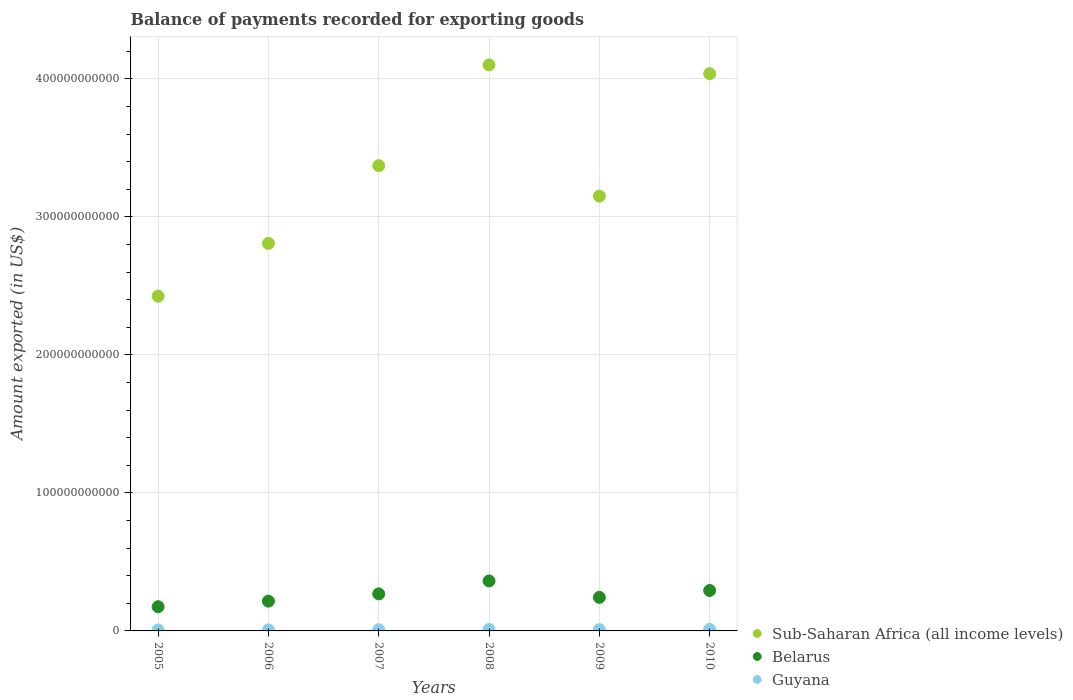How many different coloured dotlines are there?
Provide a succinct answer. 3. Is the number of dotlines equal to the number of legend labels?
Provide a succinct answer. Yes. What is the amount exported in Guyana in 2006?
Provide a short and direct response. 7.27e+08. Across all years, what is the maximum amount exported in Sub-Saharan Africa (all income levels)?
Provide a succinct answer. 4.10e+11. Across all years, what is the minimum amount exported in Guyana?
Your answer should be compact. 6.93e+08. In which year was the amount exported in Guyana maximum?
Offer a terse response. 2010. What is the total amount exported in Belarus in the graph?
Keep it short and to the point. 1.56e+11. What is the difference between the amount exported in Sub-Saharan Africa (all income levels) in 2005 and that in 2008?
Your answer should be very brief. -1.68e+11. What is the difference between the amount exported in Guyana in 2006 and the amount exported in Sub-Saharan Africa (all income levels) in 2007?
Make the answer very short. -3.36e+11. What is the average amount exported in Guyana per year?
Make the answer very short. 8.90e+08. In the year 2008, what is the difference between the amount exported in Belarus and amount exported in Sub-Saharan Africa (all income levels)?
Provide a short and direct response. -3.74e+11. What is the ratio of the amount exported in Belarus in 2007 to that in 2008?
Your response must be concise. 0.74. Is the amount exported in Sub-Saharan Africa (all income levels) in 2005 less than that in 2006?
Offer a terse response. Yes. Is the difference between the amount exported in Belarus in 2009 and 2010 greater than the difference between the amount exported in Sub-Saharan Africa (all income levels) in 2009 and 2010?
Your response must be concise. Yes. What is the difference between the highest and the second highest amount exported in Guyana?
Give a very brief answer. 1.06e+08. What is the difference between the highest and the lowest amount exported in Guyana?
Offer a very short reply. 4.26e+08. Is the sum of the amount exported in Guyana in 2005 and 2008 greater than the maximum amount exported in Belarus across all years?
Give a very brief answer. No. Does the amount exported in Sub-Saharan Africa (all income levels) monotonically increase over the years?
Your answer should be very brief. No. What is the difference between two consecutive major ticks on the Y-axis?
Make the answer very short. 1.00e+11. Does the graph contain grids?
Your response must be concise. Yes. How many legend labels are there?
Provide a succinct answer. 3. How are the legend labels stacked?
Offer a terse response. Vertical. What is the title of the graph?
Provide a short and direct response. Balance of payments recorded for exporting goods. Does "Nigeria" appear as one of the legend labels in the graph?
Your response must be concise. No. What is the label or title of the X-axis?
Your answer should be very brief. Years. What is the label or title of the Y-axis?
Give a very brief answer. Amount exported (in US$). What is the Amount exported (in US$) of Sub-Saharan Africa (all income levels) in 2005?
Make the answer very short. 2.43e+11. What is the Amount exported (in US$) of Belarus in 2005?
Provide a succinct answer. 1.75e+1. What is the Amount exported (in US$) of Guyana in 2005?
Your answer should be very brief. 6.93e+08. What is the Amount exported (in US$) in Sub-Saharan Africa (all income levels) in 2006?
Offer a terse response. 2.81e+11. What is the Amount exported (in US$) of Belarus in 2006?
Offer a very short reply. 2.16e+1. What is the Amount exported (in US$) in Guyana in 2006?
Keep it short and to the point. 7.27e+08. What is the Amount exported (in US$) of Sub-Saharan Africa (all income levels) in 2007?
Your answer should be very brief. 3.37e+11. What is the Amount exported (in US$) of Belarus in 2007?
Offer a terse response. 2.69e+1. What is the Amount exported (in US$) in Guyana in 2007?
Make the answer very short. 8.48e+08. What is the Amount exported (in US$) of Sub-Saharan Africa (all income levels) in 2008?
Your answer should be compact. 4.10e+11. What is the Amount exported (in US$) of Belarus in 2008?
Provide a short and direct response. 3.62e+1. What is the Amount exported (in US$) of Guyana in 2008?
Ensure brevity in your answer.  1.01e+09. What is the Amount exported (in US$) of Sub-Saharan Africa (all income levels) in 2009?
Your answer should be very brief. 3.15e+11. What is the Amount exported (in US$) of Belarus in 2009?
Ensure brevity in your answer.  2.43e+1. What is the Amount exported (in US$) of Guyana in 2009?
Give a very brief answer. 9.38e+08. What is the Amount exported (in US$) of Sub-Saharan Africa (all income levels) in 2010?
Offer a very short reply. 4.04e+11. What is the Amount exported (in US$) in Belarus in 2010?
Make the answer very short. 2.93e+1. What is the Amount exported (in US$) in Guyana in 2010?
Your answer should be very brief. 1.12e+09. Across all years, what is the maximum Amount exported (in US$) of Sub-Saharan Africa (all income levels)?
Give a very brief answer. 4.10e+11. Across all years, what is the maximum Amount exported (in US$) in Belarus?
Offer a terse response. 3.62e+1. Across all years, what is the maximum Amount exported (in US$) of Guyana?
Your response must be concise. 1.12e+09. Across all years, what is the minimum Amount exported (in US$) in Sub-Saharan Africa (all income levels)?
Your response must be concise. 2.43e+11. Across all years, what is the minimum Amount exported (in US$) of Belarus?
Provide a short and direct response. 1.75e+1. Across all years, what is the minimum Amount exported (in US$) of Guyana?
Offer a terse response. 6.93e+08. What is the total Amount exported (in US$) in Sub-Saharan Africa (all income levels) in the graph?
Keep it short and to the point. 1.99e+12. What is the total Amount exported (in US$) in Belarus in the graph?
Provide a short and direct response. 1.56e+11. What is the total Amount exported (in US$) of Guyana in the graph?
Give a very brief answer. 5.34e+09. What is the difference between the Amount exported (in US$) of Sub-Saharan Africa (all income levels) in 2005 and that in 2006?
Keep it short and to the point. -3.83e+1. What is the difference between the Amount exported (in US$) in Belarus in 2005 and that in 2006?
Offer a very short reply. -4.03e+09. What is the difference between the Amount exported (in US$) of Guyana in 2005 and that in 2006?
Provide a short and direct response. -3.37e+07. What is the difference between the Amount exported (in US$) of Sub-Saharan Africa (all income levels) in 2005 and that in 2007?
Provide a succinct answer. -9.46e+1. What is the difference between the Amount exported (in US$) in Belarus in 2005 and that in 2007?
Offer a very short reply. -9.32e+09. What is the difference between the Amount exported (in US$) in Guyana in 2005 and that in 2007?
Keep it short and to the point. -1.54e+08. What is the difference between the Amount exported (in US$) of Sub-Saharan Africa (all income levels) in 2005 and that in 2008?
Keep it short and to the point. -1.68e+11. What is the difference between the Amount exported (in US$) of Belarus in 2005 and that in 2008?
Your answer should be very brief. -1.87e+1. What is the difference between the Amount exported (in US$) of Guyana in 2005 and that in 2008?
Your answer should be very brief. -3.20e+08. What is the difference between the Amount exported (in US$) of Sub-Saharan Africa (all income levels) in 2005 and that in 2009?
Ensure brevity in your answer.  -7.25e+1. What is the difference between the Amount exported (in US$) of Belarus in 2005 and that in 2009?
Your answer should be very brief. -6.77e+09. What is the difference between the Amount exported (in US$) in Guyana in 2005 and that in 2009?
Offer a terse response. -2.45e+08. What is the difference between the Amount exported (in US$) in Sub-Saharan Africa (all income levels) in 2005 and that in 2010?
Keep it short and to the point. -1.61e+11. What is the difference between the Amount exported (in US$) in Belarus in 2005 and that in 2010?
Offer a terse response. -1.18e+1. What is the difference between the Amount exported (in US$) in Guyana in 2005 and that in 2010?
Keep it short and to the point. -4.26e+08. What is the difference between the Amount exported (in US$) of Sub-Saharan Africa (all income levels) in 2006 and that in 2007?
Provide a short and direct response. -5.63e+1. What is the difference between the Amount exported (in US$) of Belarus in 2006 and that in 2007?
Provide a short and direct response. -5.28e+09. What is the difference between the Amount exported (in US$) in Guyana in 2006 and that in 2007?
Your response must be concise. -1.21e+08. What is the difference between the Amount exported (in US$) in Sub-Saharan Africa (all income levels) in 2006 and that in 2008?
Provide a succinct answer. -1.29e+11. What is the difference between the Amount exported (in US$) of Belarus in 2006 and that in 2008?
Keep it short and to the point. -1.46e+1. What is the difference between the Amount exported (in US$) of Guyana in 2006 and that in 2008?
Provide a short and direct response. -2.86e+08. What is the difference between the Amount exported (in US$) of Sub-Saharan Africa (all income levels) in 2006 and that in 2009?
Offer a very short reply. -3.43e+1. What is the difference between the Amount exported (in US$) of Belarus in 2006 and that in 2009?
Your response must be concise. -2.74e+09. What is the difference between the Amount exported (in US$) of Guyana in 2006 and that in 2009?
Offer a very short reply. -2.11e+08. What is the difference between the Amount exported (in US$) in Sub-Saharan Africa (all income levels) in 2006 and that in 2010?
Make the answer very short. -1.23e+11. What is the difference between the Amount exported (in US$) of Belarus in 2006 and that in 2010?
Your answer should be compact. -7.73e+09. What is the difference between the Amount exported (in US$) in Guyana in 2006 and that in 2010?
Provide a succinct answer. -3.92e+08. What is the difference between the Amount exported (in US$) in Sub-Saharan Africa (all income levels) in 2007 and that in 2008?
Offer a terse response. -7.31e+1. What is the difference between the Amount exported (in US$) of Belarus in 2007 and that in 2008?
Provide a succinct answer. -9.37e+09. What is the difference between the Amount exported (in US$) in Guyana in 2007 and that in 2008?
Make the answer very short. -1.66e+08. What is the difference between the Amount exported (in US$) of Sub-Saharan Africa (all income levels) in 2007 and that in 2009?
Keep it short and to the point. 2.20e+1. What is the difference between the Amount exported (in US$) of Belarus in 2007 and that in 2009?
Your answer should be compact. 2.54e+09. What is the difference between the Amount exported (in US$) of Guyana in 2007 and that in 2009?
Ensure brevity in your answer.  -9.07e+07. What is the difference between the Amount exported (in US$) of Sub-Saharan Africa (all income levels) in 2007 and that in 2010?
Provide a short and direct response. -6.67e+1. What is the difference between the Amount exported (in US$) of Belarus in 2007 and that in 2010?
Provide a succinct answer. -2.45e+09. What is the difference between the Amount exported (in US$) of Guyana in 2007 and that in 2010?
Ensure brevity in your answer.  -2.71e+08. What is the difference between the Amount exported (in US$) of Sub-Saharan Africa (all income levels) in 2008 and that in 2009?
Provide a succinct answer. 9.51e+1. What is the difference between the Amount exported (in US$) in Belarus in 2008 and that in 2009?
Provide a succinct answer. 1.19e+1. What is the difference between the Amount exported (in US$) of Guyana in 2008 and that in 2009?
Your answer should be compact. 7.49e+07. What is the difference between the Amount exported (in US$) of Sub-Saharan Africa (all income levels) in 2008 and that in 2010?
Make the answer very short. 6.41e+09. What is the difference between the Amount exported (in US$) of Belarus in 2008 and that in 2010?
Your answer should be very brief. 6.92e+09. What is the difference between the Amount exported (in US$) of Guyana in 2008 and that in 2010?
Provide a succinct answer. -1.06e+08. What is the difference between the Amount exported (in US$) of Sub-Saharan Africa (all income levels) in 2009 and that in 2010?
Provide a succinct answer. -8.87e+1. What is the difference between the Amount exported (in US$) in Belarus in 2009 and that in 2010?
Keep it short and to the point. -4.99e+09. What is the difference between the Amount exported (in US$) of Guyana in 2009 and that in 2010?
Offer a very short reply. -1.81e+08. What is the difference between the Amount exported (in US$) of Sub-Saharan Africa (all income levels) in 2005 and the Amount exported (in US$) of Belarus in 2006?
Offer a very short reply. 2.21e+11. What is the difference between the Amount exported (in US$) of Sub-Saharan Africa (all income levels) in 2005 and the Amount exported (in US$) of Guyana in 2006?
Your response must be concise. 2.42e+11. What is the difference between the Amount exported (in US$) of Belarus in 2005 and the Amount exported (in US$) of Guyana in 2006?
Give a very brief answer. 1.68e+1. What is the difference between the Amount exported (in US$) of Sub-Saharan Africa (all income levels) in 2005 and the Amount exported (in US$) of Belarus in 2007?
Your answer should be compact. 2.16e+11. What is the difference between the Amount exported (in US$) of Sub-Saharan Africa (all income levels) in 2005 and the Amount exported (in US$) of Guyana in 2007?
Your answer should be compact. 2.42e+11. What is the difference between the Amount exported (in US$) in Belarus in 2005 and the Amount exported (in US$) in Guyana in 2007?
Your response must be concise. 1.67e+1. What is the difference between the Amount exported (in US$) in Sub-Saharan Africa (all income levels) in 2005 and the Amount exported (in US$) in Belarus in 2008?
Provide a short and direct response. 2.06e+11. What is the difference between the Amount exported (in US$) in Sub-Saharan Africa (all income levels) in 2005 and the Amount exported (in US$) in Guyana in 2008?
Give a very brief answer. 2.42e+11. What is the difference between the Amount exported (in US$) of Belarus in 2005 and the Amount exported (in US$) of Guyana in 2008?
Make the answer very short. 1.65e+1. What is the difference between the Amount exported (in US$) in Sub-Saharan Africa (all income levels) in 2005 and the Amount exported (in US$) in Belarus in 2009?
Make the answer very short. 2.18e+11. What is the difference between the Amount exported (in US$) in Sub-Saharan Africa (all income levels) in 2005 and the Amount exported (in US$) in Guyana in 2009?
Offer a very short reply. 2.42e+11. What is the difference between the Amount exported (in US$) in Belarus in 2005 and the Amount exported (in US$) in Guyana in 2009?
Give a very brief answer. 1.66e+1. What is the difference between the Amount exported (in US$) of Sub-Saharan Africa (all income levels) in 2005 and the Amount exported (in US$) of Belarus in 2010?
Offer a very short reply. 2.13e+11. What is the difference between the Amount exported (in US$) in Sub-Saharan Africa (all income levels) in 2005 and the Amount exported (in US$) in Guyana in 2010?
Keep it short and to the point. 2.41e+11. What is the difference between the Amount exported (in US$) of Belarus in 2005 and the Amount exported (in US$) of Guyana in 2010?
Make the answer very short. 1.64e+1. What is the difference between the Amount exported (in US$) of Sub-Saharan Africa (all income levels) in 2006 and the Amount exported (in US$) of Belarus in 2007?
Provide a succinct answer. 2.54e+11. What is the difference between the Amount exported (in US$) in Sub-Saharan Africa (all income levels) in 2006 and the Amount exported (in US$) in Guyana in 2007?
Offer a very short reply. 2.80e+11. What is the difference between the Amount exported (in US$) in Belarus in 2006 and the Amount exported (in US$) in Guyana in 2007?
Provide a short and direct response. 2.07e+1. What is the difference between the Amount exported (in US$) of Sub-Saharan Africa (all income levels) in 2006 and the Amount exported (in US$) of Belarus in 2008?
Your response must be concise. 2.45e+11. What is the difference between the Amount exported (in US$) of Sub-Saharan Africa (all income levels) in 2006 and the Amount exported (in US$) of Guyana in 2008?
Your response must be concise. 2.80e+11. What is the difference between the Amount exported (in US$) in Belarus in 2006 and the Amount exported (in US$) in Guyana in 2008?
Keep it short and to the point. 2.06e+1. What is the difference between the Amount exported (in US$) of Sub-Saharan Africa (all income levels) in 2006 and the Amount exported (in US$) of Belarus in 2009?
Offer a terse response. 2.57e+11. What is the difference between the Amount exported (in US$) in Sub-Saharan Africa (all income levels) in 2006 and the Amount exported (in US$) in Guyana in 2009?
Your answer should be very brief. 2.80e+11. What is the difference between the Amount exported (in US$) of Belarus in 2006 and the Amount exported (in US$) of Guyana in 2009?
Offer a very short reply. 2.06e+1. What is the difference between the Amount exported (in US$) of Sub-Saharan Africa (all income levels) in 2006 and the Amount exported (in US$) of Belarus in 2010?
Your answer should be very brief. 2.52e+11. What is the difference between the Amount exported (in US$) in Sub-Saharan Africa (all income levels) in 2006 and the Amount exported (in US$) in Guyana in 2010?
Make the answer very short. 2.80e+11. What is the difference between the Amount exported (in US$) of Belarus in 2006 and the Amount exported (in US$) of Guyana in 2010?
Offer a terse response. 2.05e+1. What is the difference between the Amount exported (in US$) in Sub-Saharan Africa (all income levels) in 2007 and the Amount exported (in US$) in Belarus in 2008?
Give a very brief answer. 3.01e+11. What is the difference between the Amount exported (in US$) in Sub-Saharan Africa (all income levels) in 2007 and the Amount exported (in US$) in Guyana in 2008?
Provide a succinct answer. 3.36e+11. What is the difference between the Amount exported (in US$) of Belarus in 2007 and the Amount exported (in US$) of Guyana in 2008?
Offer a terse response. 2.58e+1. What is the difference between the Amount exported (in US$) in Sub-Saharan Africa (all income levels) in 2007 and the Amount exported (in US$) in Belarus in 2009?
Provide a succinct answer. 3.13e+11. What is the difference between the Amount exported (in US$) of Sub-Saharan Africa (all income levels) in 2007 and the Amount exported (in US$) of Guyana in 2009?
Ensure brevity in your answer.  3.36e+11. What is the difference between the Amount exported (in US$) of Belarus in 2007 and the Amount exported (in US$) of Guyana in 2009?
Offer a terse response. 2.59e+1. What is the difference between the Amount exported (in US$) of Sub-Saharan Africa (all income levels) in 2007 and the Amount exported (in US$) of Belarus in 2010?
Offer a terse response. 3.08e+11. What is the difference between the Amount exported (in US$) in Sub-Saharan Africa (all income levels) in 2007 and the Amount exported (in US$) in Guyana in 2010?
Provide a short and direct response. 3.36e+11. What is the difference between the Amount exported (in US$) of Belarus in 2007 and the Amount exported (in US$) of Guyana in 2010?
Give a very brief answer. 2.57e+1. What is the difference between the Amount exported (in US$) in Sub-Saharan Africa (all income levels) in 2008 and the Amount exported (in US$) in Belarus in 2009?
Your response must be concise. 3.86e+11. What is the difference between the Amount exported (in US$) of Sub-Saharan Africa (all income levels) in 2008 and the Amount exported (in US$) of Guyana in 2009?
Provide a short and direct response. 4.09e+11. What is the difference between the Amount exported (in US$) of Belarus in 2008 and the Amount exported (in US$) of Guyana in 2009?
Provide a short and direct response. 3.53e+1. What is the difference between the Amount exported (in US$) in Sub-Saharan Africa (all income levels) in 2008 and the Amount exported (in US$) in Belarus in 2010?
Ensure brevity in your answer.  3.81e+11. What is the difference between the Amount exported (in US$) of Sub-Saharan Africa (all income levels) in 2008 and the Amount exported (in US$) of Guyana in 2010?
Offer a terse response. 4.09e+11. What is the difference between the Amount exported (in US$) of Belarus in 2008 and the Amount exported (in US$) of Guyana in 2010?
Provide a short and direct response. 3.51e+1. What is the difference between the Amount exported (in US$) in Sub-Saharan Africa (all income levels) in 2009 and the Amount exported (in US$) in Belarus in 2010?
Make the answer very short. 2.86e+11. What is the difference between the Amount exported (in US$) of Sub-Saharan Africa (all income levels) in 2009 and the Amount exported (in US$) of Guyana in 2010?
Keep it short and to the point. 3.14e+11. What is the difference between the Amount exported (in US$) in Belarus in 2009 and the Amount exported (in US$) in Guyana in 2010?
Give a very brief answer. 2.32e+1. What is the average Amount exported (in US$) of Sub-Saharan Africa (all income levels) per year?
Ensure brevity in your answer.  3.32e+11. What is the average Amount exported (in US$) in Belarus per year?
Provide a short and direct response. 2.60e+1. What is the average Amount exported (in US$) in Guyana per year?
Keep it short and to the point. 8.90e+08. In the year 2005, what is the difference between the Amount exported (in US$) of Sub-Saharan Africa (all income levels) and Amount exported (in US$) of Belarus?
Give a very brief answer. 2.25e+11. In the year 2005, what is the difference between the Amount exported (in US$) in Sub-Saharan Africa (all income levels) and Amount exported (in US$) in Guyana?
Ensure brevity in your answer.  2.42e+11. In the year 2005, what is the difference between the Amount exported (in US$) of Belarus and Amount exported (in US$) of Guyana?
Your response must be concise. 1.68e+1. In the year 2006, what is the difference between the Amount exported (in US$) of Sub-Saharan Africa (all income levels) and Amount exported (in US$) of Belarus?
Your answer should be compact. 2.59e+11. In the year 2006, what is the difference between the Amount exported (in US$) of Sub-Saharan Africa (all income levels) and Amount exported (in US$) of Guyana?
Your response must be concise. 2.80e+11. In the year 2006, what is the difference between the Amount exported (in US$) of Belarus and Amount exported (in US$) of Guyana?
Give a very brief answer. 2.08e+1. In the year 2007, what is the difference between the Amount exported (in US$) in Sub-Saharan Africa (all income levels) and Amount exported (in US$) in Belarus?
Offer a very short reply. 3.10e+11. In the year 2007, what is the difference between the Amount exported (in US$) of Sub-Saharan Africa (all income levels) and Amount exported (in US$) of Guyana?
Your answer should be compact. 3.36e+11. In the year 2007, what is the difference between the Amount exported (in US$) in Belarus and Amount exported (in US$) in Guyana?
Offer a terse response. 2.60e+1. In the year 2008, what is the difference between the Amount exported (in US$) of Sub-Saharan Africa (all income levels) and Amount exported (in US$) of Belarus?
Keep it short and to the point. 3.74e+11. In the year 2008, what is the difference between the Amount exported (in US$) in Sub-Saharan Africa (all income levels) and Amount exported (in US$) in Guyana?
Offer a very short reply. 4.09e+11. In the year 2008, what is the difference between the Amount exported (in US$) in Belarus and Amount exported (in US$) in Guyana?
Give a very brief answer. 3.52e+1. In the year 2009, what is the difference between the Amount exported (in US$) of Sub-Saharan Africa (all income levels) and Amount exported (in US$) of Belarus?
Your answer should be very brief. 2.91e+11. In the year 2009, what is the difference between the Amount exported (in US$) in Sub-Saharan Africa (all income levels) and Amount exported (in US$) in Guyana?
Make the answer very short. 3.14e+11. In the year 2009, what is the difference between the Amount exported (in US$) in Belarus and Amount exported (in US$) in Guyana?
Make the answer very short. 2.34e+1. In the year 2010, what is the difference between the Amount exported (in US$) of Sub-Saharan Africa (all income levels) and Amount exported (in US$) of Belarus?
Provide a succinct answer. 3.75e+11. In the year 2010, what is the difference between the Amount exported (in US$) in Sub-Saharan Africa (all income levels) and Amount exported (in US$) in Guyana?
Your answer should be compact. 4.03e+11. In the year 2010, what is the difference between the Amount exported (in US$) of Belarus and Amount exported (in US$) of Guyana?
Your answer should be very brief. 2.82e+1. What is the ratio of the Amount exported (in US$) in Sub-Saharan Africa (all income levels) in 2005 to that in 2006?
Offer a very short reply. 0.86. What is the ratio of the Amount exported (in US$) of Belarus in 2005 to that in 2006?
Make the answer very short. 0.81. What is the ratio of the Amount exported (in US$) of Guyana in 2005 to that in 2006?
Offer a very short reply. 0.95. What is the ratio of the Amount exported (in US$) of Sub-Saharan Africa (all income levels) in 2005 to that in 2007?
Offer a terse response. 0.72. What is the ratio of the Amount exported (in US$) of Belarus in 2005 to that in 2007?
Your answer should be compact. 0.65. What is the ratio of the Amount exported (in US$) of Guyana in 2005 to that in 2007?
Offer a very short reply. 0.82. What is the ratio of the Amount exported (in US$) of Sub-Saharan Africa (all income levels) in 2005 to that in 2008?
Offer a terse response. 0.59. What is the ratio of the Amount exported (in US$) of Belarus in 2005 to that in 2008?
Provide a succinct answer. 0.48. What is the ratio of the Amount exported (in US$) of Guyana in 2005 to that in 2008?
Your answer should be very brief. 0.68. What is the ratio of the Amount exported (in US$) in Sub-Saharan Africa (all income levels) in 2005 to that in 2009?
Make the answer very short. 0.77. What is the ratio of the Amount exported (in US$) in Belarus in 2005 to that in 2009?
Provide a short and direct response. 0.72. What is the ratio of the Amount exported (in US$) of Guyana in 2005 to that in 2009?
Offer a terse response. 0.74. What is the ratio of the Amount exported (in US$) of Sub-Saharan Africa (all income levels) in 2005 to that in 2010?
Provide a short and direct response. 0.6. What is the ratio of the Amount exported (in US$) in Belarus in 2005 to that in 2010?
Offer a very short reply. 0.6. What is the ratio of the Amount exported (in US$) of Guyana in 2005 to that in 2010?
Offer a terse response. 0.62. What is the ratio of the Amount exported (in US$) of Sub-Saharan Africa (all income levels) in 2006 to that in 2007?
Your response must be concise. 0.83. What is the ratio of the Amount exported (in US$) in Belarus in 2006 to that in 2007?
Provide a short and direct response. 0.8. What is the ratio of the Amount exported (in US$) in Guyana in 2006 to that in 2007?
Make the answer very short. 0.86. What is the ratio of the Amount exported (in US$) of Sub-Saharan Africa (all income levels) in 2006 to that in 2008?
Provide a short and direct response. 0.68. What is the ratio of the Amount exported (in US$) in Belarus in 2006 to that in 2008?
Offer a terse response. 0.6. What is the ratio of the Amount exported (in US$) in Guyana in 2006 to that in 2008?
Keep it short and to the point. 0.72. What is the ratio of the Amount exported (in US$) in Sub-Saharan Africa (all income levels) in 2006 to that in 2009?
Your response must be concise. 0.89. What is the ratio of the Amount exported (in US$) of Belarus in 2006 to that in 2009?
Keep it short and to the point. 0.89. What is the ratio of the Amount exported (in US$) of Guyana in 2006 to that in 2009?
Keep it short and to the point. 0.77. What is the ratio of the Amount exported (in US$) of Sub-Saharan Africa (all income levels) in 2006 to that in 2010?
Provide a succinct answer. 0.7. What is the ratio of the Amount exported (in US$) in Belarus in 2006 to that in 2010?
Your answer should be very brief. 0.74. What is the ratio of the Amount exported (in US$) in Guyana in 2006 to that in 2010?
Your answer should be compact. 0.65. What is the ratio of the Amount exported (in US$) in Sub-Saharan Africa (all income levels) in 2007 to that in 2008?
Provide a short and direct response. 0.82. What is the ratio of the Amount exported (in US$) in Belarus in 2007 to that in 2008?
Your answer should be very brief. 0.74. What is the ratio of the Amount exported (in US$) of Guyana in 2007 to that in 2008?
Provide a short and direct response. 0.84. What is the ratio of the Amount exported (in US$) in Sub-Saharan Africa (all income levels) in 2007 to that in 2009?
Keep it short and to the point. 1.07. What is the ratio of the Amount exported (in US$) of Belarus in 2007 to that in 2009?
Your answer should be very brief. 1.1. What is the ratio of the Amount exported (in US$) in Guyana in 2007 to that in 2009?
Your response must be concise. 0.9. What is the ratio of the Amount exported (in US$) in Sub-Saharan Africa (all income levels) in 2007 to that in 2010?
Offer a terse response. 0.83. What is the ratio of the Amount exported (in US$) of Belarus in 2007 to that in 2010?
Ensure brevity in your answer.  0.92. What is the ratio of the Amount exported (in US$) in Guyana in 2007 to that in 2010?
Your answer should be compact. 0.76. What is the ratio of the Amount exported (in US$) in Sub-Saharan Africa (all income levels) in 2008 to that in 2009?
Offer a very short reply. 1.3. What is the ratio of the Amount exported (in US$) of Belarus in 2008 to that in 2009?
Your response must be concise. 1.49. What is the ratio of the Amount exported (in US$) of Guyana in 2008 to that in 2009?
Offer a very short reply. 1.08. What is the ratio of the Amount exported (in US$) of Sub-Saharan Africa (all income levels) in 2008 to that in 2010?
Your answer should be very brief. 1.02. What is the ratio of the Amount exported (in US$) in Belarus in 2008 to that in 2010?
Provide a succinct answer. 1.24. What is the ratio of the Amount exported (in US$) of Guyana in 2008 to that in 2010?
Make the answer very short. 0.91. What is the ratio of the Amount exported (in US$) of Sub-Saharan Africa (all income levels) in 2009 to that in 2010?
Offer a terse response. 0.78. What is the ratio of the Amount exported (in US$) of Belarus in 2009 to that in 2010?
Ensure brevity in your answer.  0.83. What is the ratio of the Amount exported (in US$) of Guyana in 2009 to that in 2010?
Provide a short and direct response. 0.84. What is the difference between the highest and the second highest Amount exported (in US$) in Sub-Saharan Africa (all income levels)?
Keep it short and to the point. 6.41e+09. What is the difference between the highest and the second highest Amount exported (in US$) in Belarus?
Offer a terse response. 6.92e+09. What is the difference between the highest and the second highest Amount exported (in US$) of Guyana?
Your answer should be very brief. 1.06e+08. What is the difference between the highest and the lowest Amount exported (in US$) in Sub-Saharan Africa (all income levels)?
Offer a terse response. 1.68e+11. What is the difference between the highest and the lowest Amount exported (in US$) of Belarus?
Give a very brief answer. 1.87e+1. What is the difference between the highest and the lowest Amount exported (in US$) in Guyana?
Offer a terse response. 4.26e+08. 